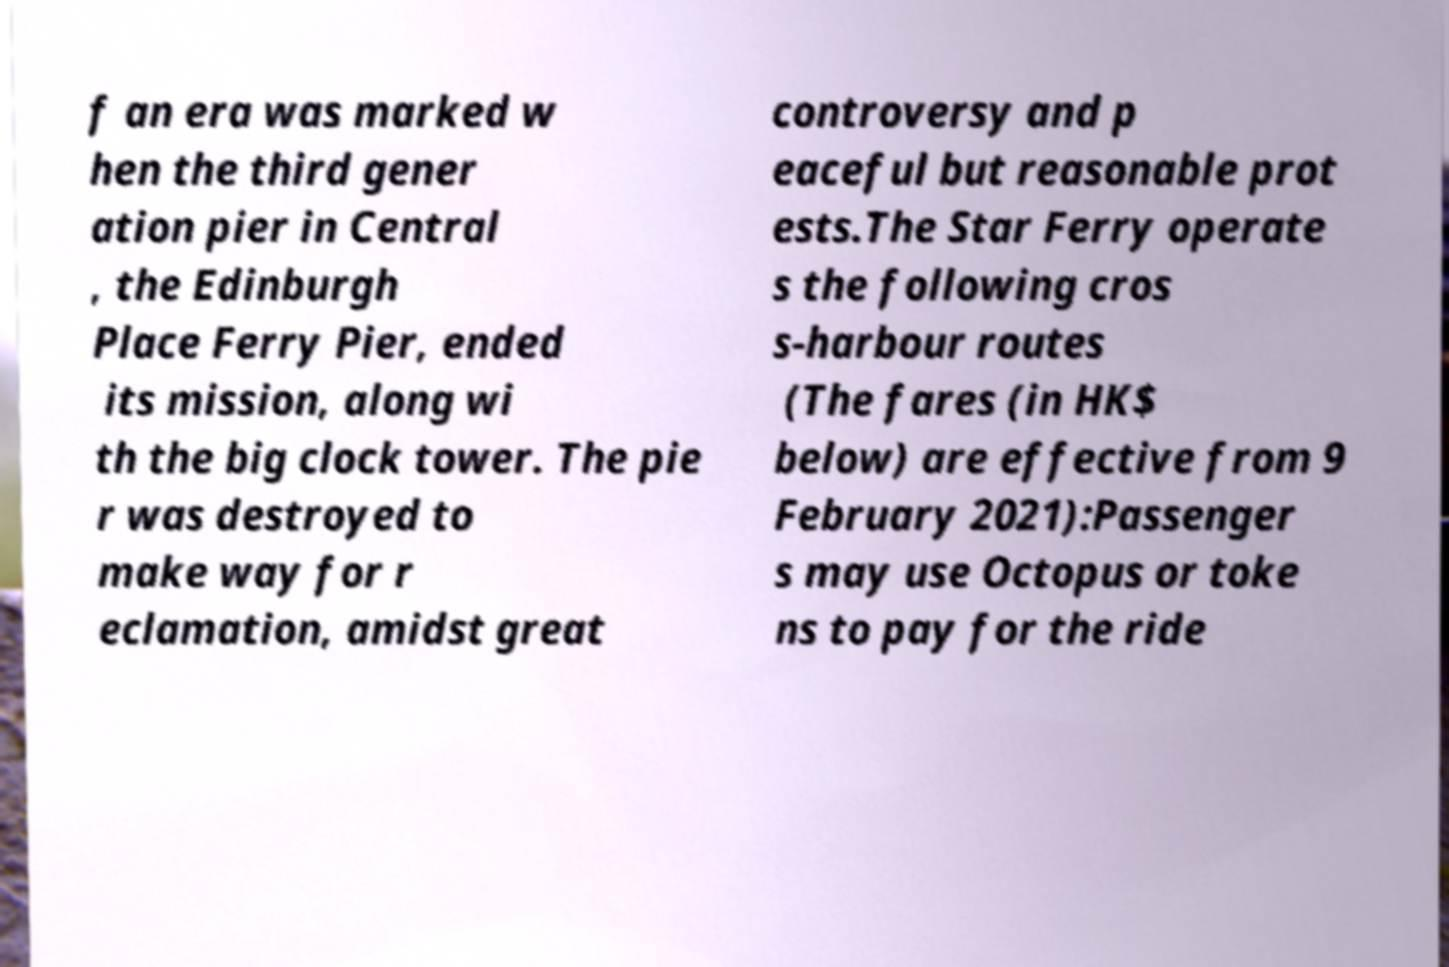There's text embedded in this image that I need extracted. Can you transcribe it verbatim? f an era was marked w hen the third gener ation pier in Central , the Edinburgh Place Ferry Pier, ended its mission, along wi th the big clock tower. The pie r was destroyed to make way for r eclamation, amidst great controversy and p eaceful but reasonable prot ests.The Star Ferry operate s the following cros s-harbour routes (The fares (in HK$ below) are effective from 9 February 2021):Passenger s may use Octopus or toke ns to pay for the ride 